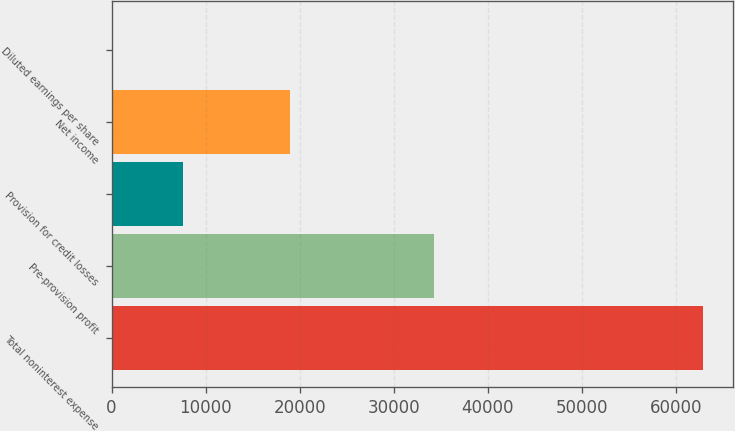<chart> <loc_0><loc_0><loc_500><loc_500><bar_chart><fcel>Total noninterest expense<fcel>Pre-provision profit<fcel>Provision for credit losses<fcel>Net income<fcel>Diluted earnings per share<nl><fcel>62911<fcel>34323<fcel>7574<fcel>18976<fcel>4.48<nl></chart> 